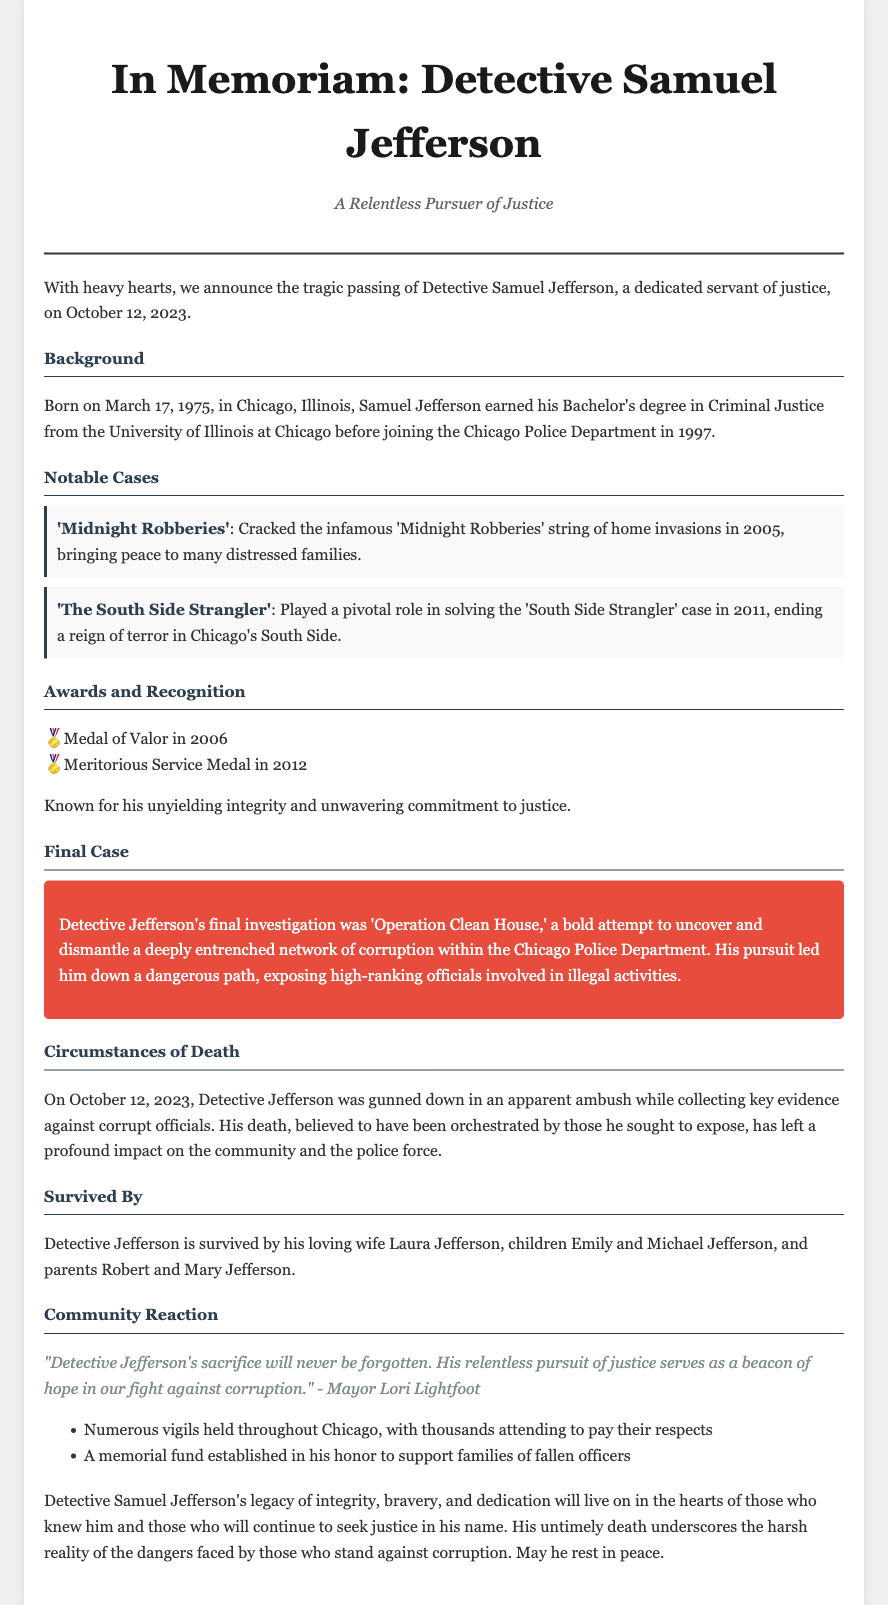What was the date of Detective Jefferson's passing? The date mentioned for Detective Jefferson's passing is October 12, 2023.
Answer: October 12, 2023 Who was Detective Jefferson's final investigation against? His final investigation was against a network of corruption within the Chicago Police Department.
Answer: Corruption within the Chicago Police Department What degree did Detective Jefferson earn? He earned a Bachelor's degree in Criminal Justice.
Answer: Bachelor's degree in Criminal Justice How many children did Detective Jefferson have? The document states that he had two children, Emily and Michael.
Answer: Two What did Mayor Lori Lightfoot say about Detective Jefferson? Mayor Lori Lightfoot mentioned that his sacrifice would never be forgotten.
Answer: His sacrifice will never be forgotten What significant award did Detective Jefferson receive in 2006? The significant award he received in 2006 is the Medal of Valor.
Answer: Medal of Valor What was the title of the case Detective Jefferson cracked in 2005? The title of the case he cracked in 2005 was 'Midnight Robberies'.
Answer: 'Midnight Robberies' How did Detective Jefferson die? He was gunned down in an apparent ambush.
Answer: Gunned down in an apparent ambush What has been established in Detective Jefferson's honor? A memorial fund has been established in his honor.
Answer: A memorial fund 